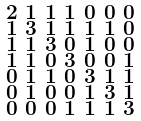<formula> <loc_0><loc_0><loc_500><loc_500>\begin{smallmatrix} 2 & 1 & 1 & 1 & 0 & 0 & 0 \\ 1 & 3 & 1 & 1 & 1 & 1 & 0 \\ 1 & 1 & 3 & 0 & 1 & 0 & 0 \\ 1 & 1 & 0 & 3 & 0 & 0 & 1 \\ 0 & 1 & 1 & 0 & 3 & 1 & 1 \\ 0 & 1 & 0 & 0 & 1 & 3 & 1 \\ 0 & 0 & 0 & 1 & 1 & 1 & 3 \end{smallmatrix}</formula> 